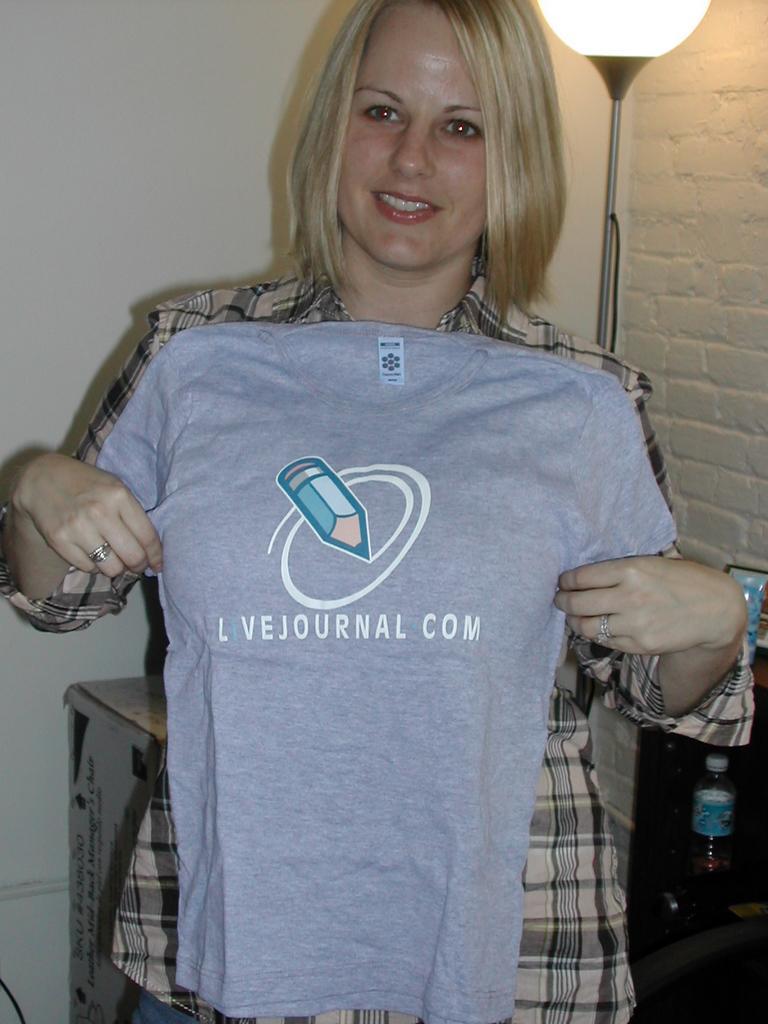Please provide a concise description of this image. This is the picture of a room. In this image there is a woman standing and smiling and she is holding the t-shirt. At the back there is a light and there is a bottle on the table and at the back there is a cardboard box and wall. 